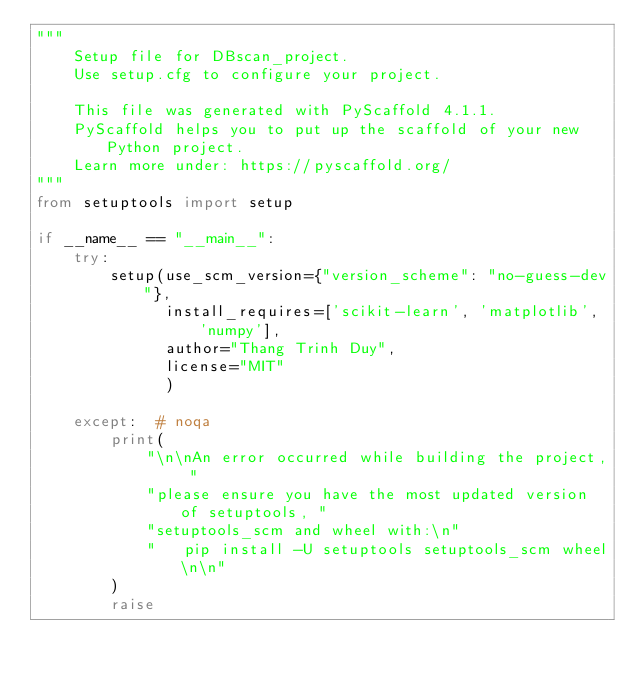Convert code to text. <code><loc_0><loc_0><loc_500><loc_500><_Python_>"""
    Setup file for DBscan_project.
    Use setup.cfg to configure your project.

    This file was generated with PyScaffold 4.1.1.
    PyScaffold helps you to put up the scaffold of your new Python project.
    Learn more under: https://pyscaffold.org/
"""
from setuptools import setup

if __name__ == "__main__":
    try:
        setup(use_scm_version={"version_scheme": "no-guess-dev"},
              install_requires=['scikit-learn', 'matplotlib', 'numpy'],
              author="Thang Trinh Duy",
              license="MIT"
              )

    except:  # noqa
        print(
            "\n\nAn error occurred while building the project, "
            "please ensure you have the most updated version of setuptools, "
            "setuptools_scm and wheel with:\n"
            "   pip install -U setuptools setuptools_scm wheel\n\n"
        )
        raise
</code> 